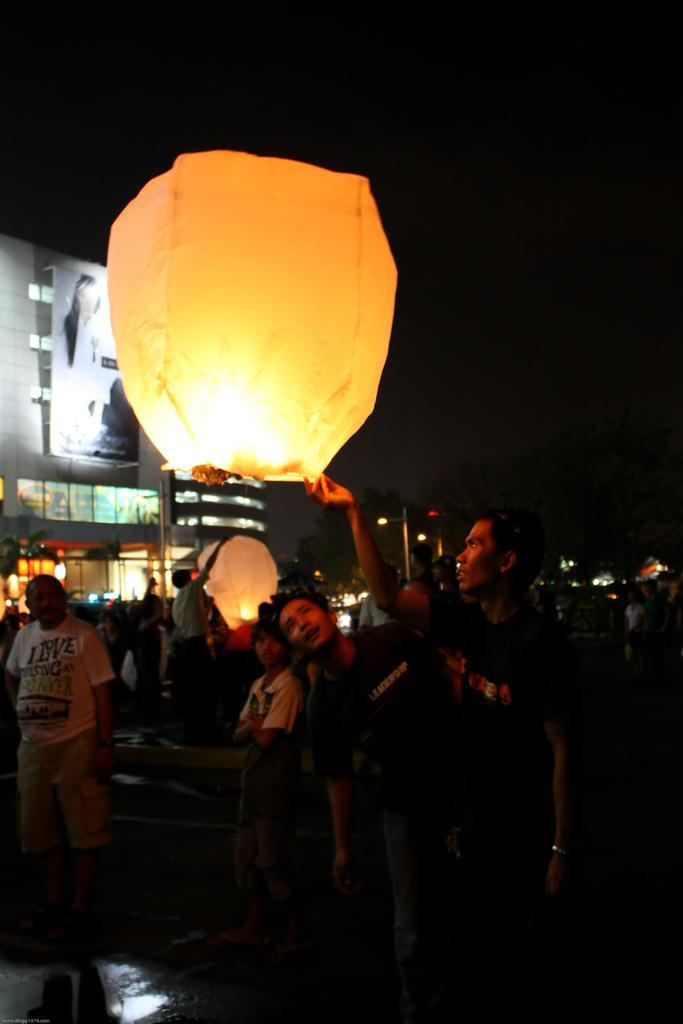Describe this image in one or two sentences. In this picture we can see a group of people, lanterns, building, banner, lights, some objects and in the background it is dark. 